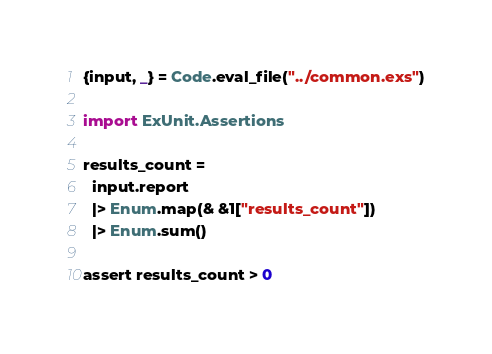Convert code to text. <code><loc_0><loc_0><loc_500><loc_500><_Elixir_>{input, _} = Code.eval_file("../common.exs")

import ExUnit.Assertions

results_count =
  input.report
  |> Enum.map(& &1["results_count"])
  |> Enum.sum()

assert results_count > 0
</code> 